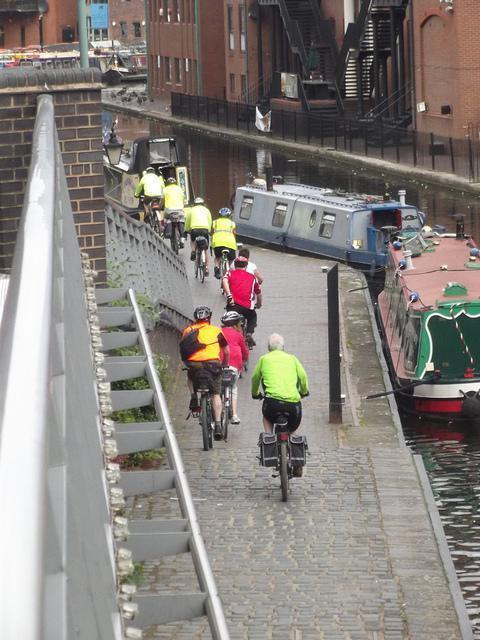Why are some cyclists wearing yellow?
Choose the correct response and explain in the format: 'Answer: answer
Rationale: rationale.'
Options: Uniform, costume, visibility, style. Answer: visibility.
Rationale: They are wearing safety vests so they are easier to see. 